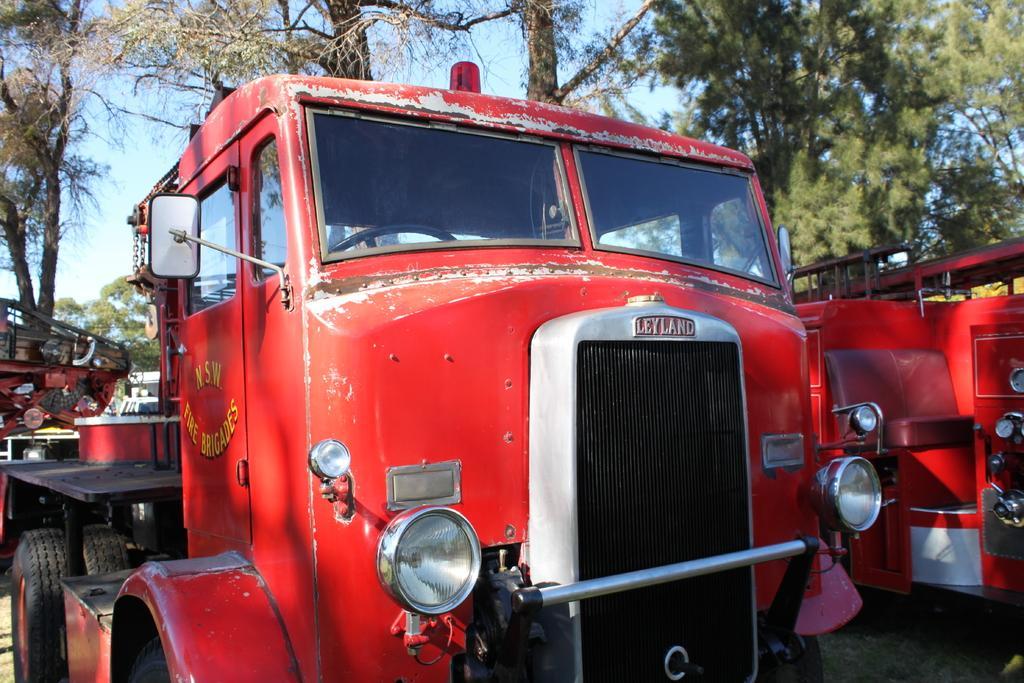Could you give a brief overview of what you see in this image? In this image we can see group of vehicles in red color are parked on the ground. On one vehicle we can see group of headlights ,mirrors. In the background we can see group of trees and sky. 